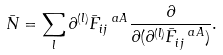<formula> <loc_0><loc_0><loc_500><loc_500>\bar { N } = \sum _ { l } \partial ^ { ( l ) } \bar { F } ^ { \ a A } _ { i j } \frac { \partial } { \partial ( \partial ^ { ( l ) } \bar { F } ^ { \ a A } _ { i j } ) } .</formula> 